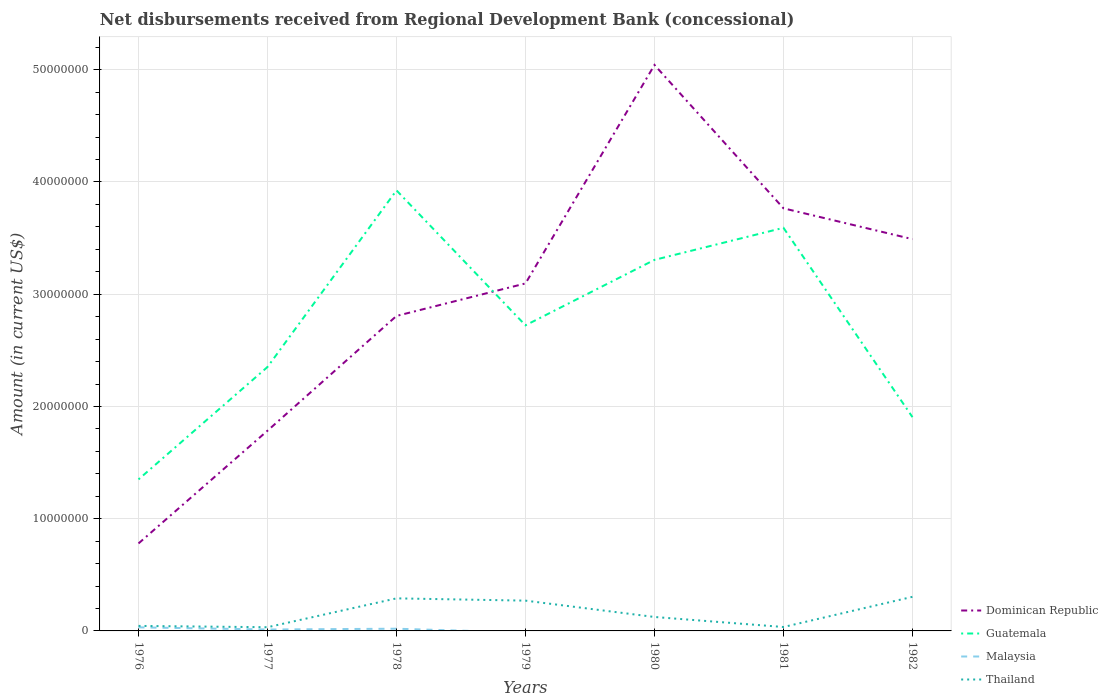Does the line corresponding to Dominican Republic intersect with the line corresponding to Thailand?
Offer a terse response. No. Across all years, what is the maximum amount of disbursements received from Regional Development Bank in Thailand?
Offer a terse response. 3.30e+05. What is the total amount of disbursements received from Regional Development Bank in Dominican Republic in the graph?
Offer a very short reply. 1.28e+07. What is the difference between the highest and the second highest amount of disbursements received from Regional Development Bank in Thailand?
Your answer should be very brief. 2.71e+06. What is the difference between the highest and the lowest amount of disbursements received from Regional Development Bank in Thailand?
Make the answer very short. 3. How many lines are there?
Your answer should be compact. 4. How many years are there in the graph?
Your response must be concise. 7. What is the difference between two consecutive major ticks on the Y-axis?
Provide a succinct answer. 1.00e+07. Where does the legend appear in the graph?
Your answer should be very brief. Bottom right. What is the title of the graph?
Your answer should be compact. Net disbursements received from Regional Development Bank (concessional). Does "Madagascar" appear as one of the legend labels in the graph?
Provide a succinct answer. No. What is the label or title of the X-axis?
Your answer should be very brief. Years. What is the label or title of the Y-axis?
Ensure brevity in your answer.  Amount (in current US$). What is the Amount (in current US$) of Dominican Republic in 1976?
Offer a very short reply. 7.79e+06. What is the Amount (in current US$) in Guatemala in 1976?
Make the answer very short. 1.35e+07. What is the Amount (in current US$) of Malaysia in 1976?
Offer a very short reply. 3.18e+05. What is the Amount (in current US$) in Thailand in 1976?
Provide a short and direct response. 4.47e+05. What is the Amount (in current US$) of Dominican Republic in 1977?
Provide a succinct answer. 1.78e+07. What is the Amount (in current US$) of Guatemala in 1977?
Make the answer very short. 2.35e+07. What is the Amount (in current US$) in Malaysia in 1977?
Your answer should be very brief. 1.26e+05. What is the Amount (in current US$) of Thailand in 1977?
Make the answer very short. 3.30e+05. What is the Amount (in current US$) of Dominican Republic in 1978?
Your answer should be very brief. 2.81e+07. What is the Amount (in current US$) in Guatemala in 1978?
Your response must be concise. 3.93e+07. What is the Amount (in current US$) of Malaysia in 1978?
Make the answer very short. 1.97e+05. What is the Amount (in current US$) in Thailand in 1978?
Your response must be concise. 2.90e+06. What is the Amount (in current US$) in Dominican Republic in 1979?
Your response must be concise. 3.10e+07. What is the Amount (in current US$) of Guatemala in 1979?
Ensure brevity in your answer.  2.72e+07. What is the Amount (in current US$) in Malaysia in 1979?
Your response must be concise. 0. What is the Amount (in current US$) of Thailand in 1979?
Your answer should be very brief. 2.70e+06. What is the Amount (in current US$) in Dominican Republic in 1980?
Give a very brief answer. 5.04e+07. What is the Amount (in current US$) in Guatemala in 1980?
Your response must be concise. 3.31e+07. What is the Amount (in current US$) of Thailand in 1980?
Provide a succinct answer. 1.24e+06. What is the Amount (in current US$) in Dominican Republic in 1981?
Your answer should be very brief. 3.77e+07. What is the Amount (in current US$) in Guatemala in 1981?
Ensure brevity in your answer.  3.59e+07. What is the Amount (in current US$) of Thailand in 1981?
Keep it short and to the point. 3.49e+05. What is the Amount (in current US$) of Dominican Republic in 1982?
Your answer should be very brief. 3.49e+07. What is the Amount (in current US$) in Guatemala in 1982?
Provide a succinct answer. 1.90e+07. What is the Amount (in current US$) in Malaysia in 1982?
Provide a short and direct response. 0. What is the Amount (in current US$) in Thailand in 1982?
Your answer should be compact. 3.04e+06. Across all years, what is the maximum Amount (in current US$) in Dominican Republic?
Make the answer very short. 5.04e+07. Across all years, what is the maximum Amount (in current US$) in Guatemala?
Give a very brief answer. 3.93e+07. Across all years, what is the maximum Amount (in current US$) in Malaysia?
Your response must be concise. 3.18e+05. Across all years, what is the maximum Amount (in current US$) of Thailand?
Offer a very short reply. 3.04e+06. Across all years, what is the minimum Amount (in current US$) in Dominican Republic?
Offer a very short reply. 7.79e+06. Across all years, what is the minimum Amount (in current US$) of Guatemala?
Ensure brevity in your answer.  1.35e+07. Across all years, what is the minimum Amount (in current US$) of Malaysia?
Your answer should be very brief. 0. What is the total Amount (in current US$) of Dominican Republic in the graph?
Make the answer very short. 2.08e+08. What is the total Amount (in current US$) of Guatemala in the graph?
Offer a very short reply. 1.92e+08. What is the total Amount (in current US$) in Malaysia in the graph?
Ensure brevity in your answer.  6.41e+05. What is the total Amount (in current US$) in Thailand in the graph?
Give a very brief answer. 1.10e+07. What is the difference between the Amount (in current US$) in Dominican Republic in 1976 and that in 1977?
Offer a very short reply. -1.00e+07. What is the difference between the Amount (in current US$) of Guatemala in 1976 and that in 1977?
Give a very brief answer. -1.00e+07. What is the difference between the Amount (in current US$) of Malaysia in 1976 and that in 1977?
Keep it short and to the point. 1.92e+05. What is the difference between the Amount (in current US$) of Thailand in 1976 and that in 1977?
Offer a very short reply. 1.17e+05. What is the difference between the Amount (in current US$) of Dominican Republic in 1976 and that in 1978?
Offer a very short reply. -2.03e+07. What is the difference between the Amount (in current US$) of Guatemala in 1976 and that in 1978?
Provide a short and direct response. -2.58e+07. What is the difference between the Amount (in current US$) in Malaysia in 1976 and that in 1978?
Offer a very short reply. 1.21e+05. What is the difference between the Amount (in current US$) of Thailand in 1976 and that in 1978?
Your answer should be compact. -2.45e+06. What is the difference between the Amount (in current US$) in Dominican Republic in 1976 and that in 1979?
Give a very brief answer. -2.32e+07. What is the difference between the Amount (in current US$) of Guatemala in 1976 and that in 1979?
Your answer should be compact. -1.37e+07. What is the difference between the Amount (in current US$) of Thailand in 1976 and that in 1979?
Provide a short and direct response. -2.25e+06. What is the difference between the Amount (in current US$) of Dominican Republic in 1976 and that in 1980?
Your answer should be very brief. -4.26e+07. What is the difference between the Amount (in current US$) in Guatemala in 1976 and that in 1980?
Provide a succinct answer. -1.96e+07. What is the difference between the Amount (in current US$) of Thailand in 1976 and that in 1980?
Keep it short and to the point. -7.95e+05. What is the difference between the Amount (in current US$) of Dominican Republic in 1976 and that in 1981?
Your response must be concise. -2.99e+07. What is the difference between the Amount (in current US$) in Guatemala in 1976 and that in 1981?
Make the answer very short. -2.24e+07. What is the difference between the Amount (in current US$) of Thailand in 1976 and that in 1981?
Your response must be concise. 9.80e+04. What is the difference between the Amount (in current US$) in Dominican Republic in 1976 and that in 1982?
Provide a short and direct response. -2.71e+07. What is the difference between the Amount (in current US$) in Guatemala in 1976 and that in 1982?
Your answer should be compact. -5.55e+06. What is the difference between the Amount (in current US$) of Thailand in 1976 and that in 1982?
Your response must be concise. -2.59e+06. What is the difference between the Amount (in current US$) in Dominican Republic in 1977 and that in 1978?
Provide a short and direct response. -1.02e+07. What is the difference between the Amount (in current US$) in Guatemala in 1977 and that in 1978?
Ensure brevity in your answer.  -1.57e+07. What is the difference between the Amount (in current US$) of Malaysia in 1977 and that in 1978?
Keep it short and to the point. -7.10e+04. What is the difference between the Amount (in current US$) in Thailand in 1977 and that in 1978?
Make the answer very short. -2.57e+06. What is the difference between the Amount (in current US$) in Dominican Republic in 1977 and that in 1979?
Provide a short and direct response. -1.31e+07. What is the difference between the Amount (in current US$) in Guatemala in 1977 and that in 1979?
Give a very brief answer. -3.71e+06. What is the difference between the Amount (in current US$) of Thailand in 1977 and that in 1979?
Provide a short and direct response. -2.37e+06. What is the difference between the Amount (in current US$) of Dominican Republic in 1977 and that in 1980?
Provide a short and direct response. -3.26e+07. What is the difference between the Amount (in current US$) of Guatemala in 1977 and that in 1980?
Your response must be concise. -9.54e+06. What is the difference between the Amount (in current US$) in Thailand in 1977 and that in 1980?
Ensure brevity in your answer.  -9.12e+05. What is the difference between the Amount (in current US$) of Dominican Republic in 1977 and that in 1981?
Offer a terse response. -1.98e+07. What is the difference between the Amount (in current US$) in Guatemala in 1977 and that in 1981?
Provide a succinct answer. -1.24e+07. What is the difference between the Amount (in current US$) in Thailand in 1977 and that in 1981?
Your answer should be compact. -1.90e+04. What is the difference between the Amount (in current US$) in Dominican Republic in 1977 and that in 1982?
Provide a short and direct response. -1.71e+07. What is the difference between the Amount (in current US$) of Guatemala in 1977 and that in 1982?
Keep it short and to the point. 4.47e+06. What is the difference between the Amount (in current US$) in Thailand in 1977 and that in 1982?
Your answer should be very brief. -2.71e+06. What is the difference between the Amount (in current US$) of Dominican Republic in 1978 and that in 1979?
Provide a succinct answer. -2.90e+06. What is the difference between the Amount (in current US$) of Guatemala in 1978 and that in 1979?
Give a very brief answer. 1.20e+07. What is the difference between the Amount (in current US$) in Thailand in 1978 and that in 1979?
Offer a terse response. 2.03e+05. What is the difference between the Amount (in current US$) of Dominican Republic in 1978 and that in 1980?
Your answer should be very brief. -2.24e+07. What is the difference between the Amount (in current US$) in Guatemala in 1978 and that in 1980?
Ensure brevity in your answer.  6.19e+06. What is the difference between the Amount (in current US$) in Thailand in 1978 and that in 1980?
Your answer should be compact. 1.66e+06. What is the difference between the Amount (in current US$) of Dominican Republic in 1978 and that in 1981?
Offer a terse response. -9.59e+06. What is the difference between the Amount (in current US$) of Guatemala in 1978 and that in 1981?
Offer a terse response. 3.34e+06. What is the difference between the Amount (in current US$) of Thailand in 1978 and that in 1981?
Give a very brief answer. 2.55e+06. What is the difference between the Amount (in current US$) in Dominican Republic in 1978 and that in 1982?
Give a very brief answer. -6.84e+06. What is the difference between the Amount (in current US$) in Guatemala in 1978 and that in 1982?
Ensure brevity in your answer.  2.02e+07. What is the difference between the Amount (in current US$) of Thailand in 1978 and that in 1982?
Your answer should be very brief. -1.37e+05. What is the difference between the Amount (in current US$) in Dominican Republic in 1979 and that in 1980?
Provide a succinct answer. -1.95e+07. What is the difference between the Amount (in current US$) in Guatemala in 1979 and that in 1980?
Give a very brief answer. -5.83e+06. What is the difference between the Amount (in current US$) of Thailand in 1979 and that in 1980?
Ensure brevity in your answer.  1.46e+06. What is the difference between the Amount (in current US$) of Dominican Republic in 1979 and that in 1981?
Your answer should be compact. -6.69e+06. What is the difference between the Amount (in current US$) of Guatemala in 1979 and that in 1981?
Make the answer very short. -8.69e+06. What is the difference between the Amount (in current US$) in Thailand in 1979 and that in 1981?
Keep it short and to the point. 2.35e+06. What is the difference between the Amount (in current US$) in Dominican Republic in 1979 and that in 1982?
Your answer should be compact. -3.95e+06. What is the difference between the Amount (in current US$) in Guatemala in 1979 and that in 1982?
Ensure brevity in your answer.  8.18e+06. What is the difference between the Amount (in current US$) in Dominican Republic in 1980 and that in 1981?
Make the answer very short. 1.28e+07. What is the difference between the Amount (in current US$) of Guatemala in 1980 and that in 1981?
Keep it short and to the point. -2.86e+06. What is the difference between the Amount (in current US$) in Thailand in 1980 and that in 1981?
Keep it short and to the point. 8.93e+05. What is the difference between the Amount (in current US$) in Dominican Republic in 1980 and that in 1982?
Ensure brevity in your answer.  1.55e+07. What is the difference between the Amount (in current US$) of Guatemala in 1980 and that in 1982?
Offer a terse response. 1.40e+07. What is the difference between the Amount (in current US$) in Thailand in 1980 and that in 1982?
Give a very brief answer. -1.80e+06. What is the difference between the Amount (in current US$) in Dominican Republic in 1981 and that in 1982?
Provide a succinct answer. 2.75e+06. What is the difference between the Amount (in current US$) in Guatemala in 1981 and that in 1982?
Keep it short and to the point. 1.69e+07. What is the difference between the Amount (in current US$) in Thailand in 1981 and that in 1982?
Offer a very short reply. -2.69e+06. What is the difference between the Amount (in current US$) in Dominican Republic in 1976 and the Amount (in current US$) in Guatemala in 1977?
Offer a very short reply. -1.57e+07. What is the difference between the Amount (in current US$) in Dominican Republic in 1976 and the Amount (in current US$) in Malaysia in 1977?
Your answer should be compact. 7.67e+06. What is the difference between the Amount (in current US$) in Dominican Republic in 1976 and the Amount (in current US$) in Thailand in 1977?
Offer a very short reply. 7.46e+06. What is the difference between the Amount (in current US$) in Guatemala in 1976 and the Amount (in current US$) in Malaysia in 1977?
Provide a short and direct response. 1.34e+07. What is the difference between the Amount (in current US$) of Guatemala in 1976 and the Amount (in current US$) of Thailand in 1977?
Offer a very short reply. 1.32e+07. What is the difference between the Amount (in current US$) in Malaysia in 1976 and the Amount (in current US$) in Thailand in 1977?
Offer a terse response. -1.20e+04. What is the difference between the Amount (in current US$) in Dominican Republic in 1976 and the Amount (in current US$) in Guatemala in 1978?
Your answer should be compact. -3.15e+07. What is the difference between the Amount (in current US$) of Dominican Republic in 1976 and the Amount (in current US$) of Malaysia in 1978?
Offer a terse response. 7.60e+06. What is the difference between the Amount (in current US$) of Dominican Republic in 1976 and the Amount (in current US$) of Thailand in 1978?
Your answer should be compact. 4.89e+06. What is the difference between the Amount (in current US$) in Guatemala in 1976 and the Amount (in current US$) in Malaysia in 1978?
Give a very brief answer. 1.33e+07. What is the difference between the Amount (in current US$) of Guatemala in 1976 and the Amount (in current US$) of Thailand in 1978?
Provide a succinct answer. 1.06e+07. What is the difference between the Amount (in current US$) in Malaysia in 1976 and the Amount (in current US$) in Thailand in 1978?
Give a very brief answer. -2.58e+06. What is the difference between the Amount (in current US$) of Dominican Republic in 1976 and the Amount (in current US$) of Guatemala in 1979?
Offer a very short reply. -1.94e+07. What is the difference between the Amount (in current US$) of Dominican Republic in 1976 and the Amount (in current US$) of Thailand in 1979?
Offer a very short reply. 5.10e+06. What is the difference between the Amount (in current US$) of Guatemala in 1976 and the Amount (in current US$) of Thailand in 1979?
Offer a terse response. 1.08e+07. What is the difference between the Amount (in current US$) in Malaysia in 1976 and the Amount (in current US$) in Thailand in 1979?
Ensure brevity in your answer.  -2.38e+06. What is the difference between the Amount (in current US$) in Dominican Republic in 1976 and the Amount (in current US$) in Guatemala in 1980?
Provide a short and direct response. -2.53e+07. What is the difference between the Amount (in current US$) of Dominican Republic in 1976 and the Amount (in current US$) of Thailand in 1980?
Your response must be concise. 6.55e+06. What is the difference between the Amount (in current US$) of Guatemala in 1976 and the Amount (in current US$) of Thailand in 1980?
Offer a terse response. 1.23e+07. What is the difference between the Amount (in current US$) in Malaysia in 1976 and the Amount (in current US$) in Thailand in 1980?
Provide a succinct answer. -9.24e+05. What is the difference between the Amount (in current US$) in Dominican Republic in 1976 and the Amount (in current US$) in Guatemala in 1981?
Make the answer very short. -2.81e+07. What is the difference between the Amount (in current US$) in Dominican Republic in 1976 and the Amount (in current US$) in Thailand in 1981?
Your response must be concise. 7.44e+06. What is the difference between the Amount (in current US$) of Guatemala in 1976 and the Amount (in current US$) of Thailand in 1981?
Keep it short and to the point. 1.32e+07. What is the difference between the Amount (in current US$) in Malaysia in 1976 and the Amount (in current US$) in Thailand in 1981?
Keep it short and to the point. -3.10e+04. What is the difference between the Amount (in current US$) in Dominican Republic in 1976 and the Amount (in current US$) in Guatemala in 1982?
Make the answer very short. -1.13e+07. What is the difference between the Amount (in current US$) in Dominican Republic in 1976 and the Amount (in current US$) in Thailand in 1982?
Give a very brief answer. 4.76e+06. What is the difference between the Amount (in current US$) in Guatemala in 1976 and the Amount (in current US$) in Thailand in 1982?
Keep it short and to the point. 1.05e+07. What is the difference between the Amount (in current US$) in Malaysia in 1976 and the Amount (in current US$) in Thailand in 1982?
Offer a very short reply. -2.72e+06. What is the difference between the Amount (in current US$) of Dominican Republic in 1977 and the Amount (in current US$) of Guatemala in 1978?
Provide a short and direct response. -2.14e+07. What is the difference between the Amount (in current US$) in Dominican Republic in 1977 and the Amount (in current US$) in Malaysia in 1978?
Provide a succinct answer. 1.76e+07. What is the difference between the Amount (in current US$) in Dominican Republic in 1977 and the Amount (in current US$) in Thailand in 1978?
Make the answer very short. 1.49e+07. What is the difference between the Amount (in current US$) in Guatemala in 1977 and the Amount (in current US$) in Malaysia in 1978?
Your answer should be very brief. 2.33e+07. What is the difference between the Amount (in current US$) in Guatemala in 1977 and the Amount (in current US$) in Thailand in 1978?
Your answer should be compact. 2.06e+07. What is the difference between the Amount (in current US$) in Malaysia in 1977 and the Amount (in current US$) in Thailand in 1978?
Provide a succinct answer. -2.78e+06. What is the difference between the Amount (in current US$) in Dominican Republic in 1977 and the Amount (in current US$) in Guatemala in 1979?
Offer a very short reply. -9.39e+06. What is the difference between the Amount (in current US$) of Dominican Republic in 1977 and the Amount (in current US$) of Thailand in 1979?
Your answer should be compact. 1.51e+07. What is the difference between the Amount (in current US$) in Guatemala in 1977 and the Amount (in current US$) in Thailand in 1979?
Offer a very short reply. 2.08e+07. What is the difference between the Amount (in current US$) in Malaysia in 1977 and the Amount (in current US$) in Thailand in 1979?
Your answer should be compact. -2.57e+06. What is the difference between the Amount (in current US$) in Dominican Republic in 1977 and the Amount (in current US$) in Guatemala in 1980?
Your answer should be compact. -1.52e+07. What is the difference between the Amount (in current US$) in Dominican Republic in 1977 and the Amount (in current US$) in Thailand in 1980?
Provide a short and direct response. 1.66e+07. What is the difference between the Amount (in current US$) of Guatemala in 1977 and the Amount (in current US$) of Thailand in 1980?
Your answer should be very brief. 2.23e+07. What is the difference between the Amount (in current US$) of Malaysia in 1977 and the Amount (in current US$) of Thailand in 1980?
Your answer should be compact. -1.12e+06. What is the difference between the Amount (in current US$) in Dominican Republic in 1977 and the Amount (in current US$) in Guatemala in 1981?
Your response must be concise. -1.81e+07. What is the difference between the Amount (in current US$) in Dominican Republic in 1977 and the Amount (in current US$) in Thailand in 1981?
Make the answer very short. 1.75e+07. What is the difference between the Amount (in current US$) of Guatemala in 1977 and the Amount (in current US$) of Thailand in 1981?
Keep it short and to the point. 2.32e+07. What is the difference between the Amount (in current US$) in Malaysia in 1977 and the Amount (in current US$) in Thailand in 1981?
Give a very brief answer. -2.23e+05. What is the difference between the Amount (in current US$) of Dominican Republic in 1977 and the Amount (in current US$) of Guatemala in 1982?
Your answer should be very brief. -1.21e+06. What is the difference between the Amount (in current US$) of Dominican Republic in 1977 and the Amount (in current US$) of Thailand in 1982?
Give a very brief answer. 1.48e+07. What is the difference between the Amount (in current US$) of Guatemala in 1977 and the Amount (in current US$) of Thailand in 1982?
Offer a terse response. 2.05e+07. What is the difference between the Amount (in current US$) in Malaysia in 1977 and the Amount (in current US$) in Thailand in 1982?
Offer a terse response. -2.91e+06. What is the difference between the Amount (in current US$) in Dominican Republic in 1978 and the Amount (in current US$) in Guatemala in 1979?
Your answer should be compact. 8.38e+05. What is the difference between the Amount (in current US$) in Dominican Republic in 1978 and the Amount (in current US$) in Thailand in 1979?
Your answer should be compact. 2.54e+07. What is the difference between the Amount (in current US$) of Guatemala in 1978 and the Amount (in current US$) of Thailand in 1979?
Offer a terse response. 3.66e+07. What is the difference between the Amount (in current US$) of Malaysia in 1978 and the Amount (in current US$) of Thailand in 1979?
Make the answer very short. -2.50e+06. What is the difference between the Amount (in current US$) of Dominican Republic in 1978 and the Amount (in current US$) of Guatemala in 1980?
Offer a very short reply. -5.00e+06. What is the difference between the Amount (in current US$) in Dominican Republic in 1978 and the Amount (in current US$) in Thailand in 1980?
Your response must be concise. 2.68e+07. What is the difference between the Amount (in current US$) in Guatemala in 1978 and the Amount (in current US$) in Thailand in 1980?
Offer a terse response. 3.80e+07. What is the difference between the Amount (in current US$) in Malaysia in 1978 and the Amount (in current US$) in Thailand in 1980?
Your response must be concise. -1.04e+06. What is the difference between the Amount (in current US$) of Dominican Republic in 1978 and the Amount (in current US$) of Guatemala in 1981?
Provide a succinct answer. -7.85e+06. What is the difference between the Amount (in current US$) of Dominican Republic in 1978 and the Amount (in current US$) of Thailand in 1981?
Keep it short and to the point. 2.77e+07. What is the difference between the Amount (in current US$) of Guatemala in 1978 and the Amount (in current US$) of Thailand in 1981?
Provide a succinct answer. 3.89e+07. What is the difference between the Amount (in current US$) in Malaysia in 1978 and the Amount (in current US$) in Thailand in 1981?
Provide a short and direct response. -1.52e+05. What is the difference between the Amount (in current US$) in Dominican Republic in 1978 and the Amount (in current US$) in Guatemala in 1982?
Your response must be concise. 9.02e+06. What is the difference between the Amount (in current US$) of Dominican Republic in 1978 and the Amount (in current US$) of Thailand in 1982?
Offer a terse response. 2.50e+07. What is the difference between the Amount (in current US$) of Guatemala in 1978 and the Amount (in current US$) of Thailand in 1982?
Keep it short and to the point. 3.62e+07. What is the difference between the Amount (in current US$) of Malaysia in 1978 and the Amount (in current US$) of Thailand in 1982?
Ensure brevity in your answer.  -2.84e+06. What is the difference between the Amount (in current US$) in Dominican Republic in 1979 and the Amount (in current US$) in Guatemala in 1980?
Ensure brevity in your answer.  -2.10e+06. What is the difference between the Amount (in current US$) in Dominican Republic in 1979 and the Amount (in current US$) in Thailand in 1980?
Your answer should be very brief. 2.97e+07. What is the difference between the Amount (in current US$) in Guatemala in 1979 and the Amount (in current US$) in Thailand in 1980?
Your answer should be compact. 2.60e+07. What is the difference between the Amount (in current US$) of Dominican Republic in 1979 and the Amount (in current US$) of Guatemala in 1981?
Your response must be concise. -4.96e+06. What is the difference between the Amount (in current US$) in Dominican Republic in 1979 and the Amount (in current US$) in Thailand in 1981?
Make the answer very short. 3.06e+07. What is the difference between the Amount (in current US$) in Guatemala in 1979 and the Amount (in current US$) in Thailand in 1981?
Offer a very short reply. 2.69e+07. What is the difference between the Amount (in current US$) in Dominican Republic in 1979 and the Amount (in current US$) in Guatemala in 1982?
Give a very brief answer. 1.19e+07. What is the difference between the Amount (in current US$) in Dominican Republic in 1979 and the Amount (in current US$) in Thailand in 1982?
Your response must be concise. 2.79e+07. What is the difference between the Amount (in current US$) of Guatemala in 1979 and the Amount (in current US$) of Thailand in 1982?
Give a very brief answer. 2.42e+07. What is the difference between the Amount (in current US$) in Dominican Republic in 1980 and the Amount (in current US$) in Guatemala in 1981?
Give a very brief answer. 1.45e+07. What is the difference between the Amount (in current US$) in Dominican Republic in 1980 and the Amount (in current US$) in Thailand in 1981?
Make the answer very short. 5.01e+07. What is the difference between the Amount (in current US$) of Guatemala in 1980 and the Amount (in current US$) of Thailand in 1981?
Ensure brevity in your answer.  3.27e+07. What is the difference between the Amount (in current US$) of Dominican Republic in 1980 and the Amount (in current US$) of Guatemala in 1982?
Keep it short and to the point. 3.14e+07. What is the difference between the Amount (in current US$) of Dominican Republic in 1980 and the Amount (in current US$) of Thailand in 1982?
Provide a short and direct response. 4.74e+07. What is the difference between the Amount (in current US$) in Guatemala in 1980 and the Amount (in current US$) in Thailand in 1982?
Offer a very short reply. 3.00e+07. What is the difference between the Amount (in current US$) in Dominican Republic in 1981 and the Amount (in current US$) in Guatemala in 1982?
Offer a very short reply. 1.86e+07. What is the difference between the Amount (in current US$) of Dominican Republic in 1981 and the Amount (in current US$) of Thailand in 1982?
Provide a short and direct response. 3.46e+07. What is the difference between the Amount (in current US$) of Guatemala in 1981 and the Amount (in current US$) of Thailand in 1982?
Offer a terse response. 3.29e+07. What is the average Amount (in current US$) in Dominican Republic per year?
Provide a succinct answer. 2.97e+07. What is the average Amount (in current US$) of Guatemala per year?
Keep it short and to the point. 2.74e+07. What is the average Amount (in current US$) of Malaysia per year?
Provide a short and direct response. 9.16e+04. What is the average Amount (in current US$) in Thailand per year?
Keep it short and to the point. 1.57e+06. In the year 1976, what is the difference between the Amount (in current US$) in Dominican Republic and Amount (in current US$) in Guatemala?
Make the answer very short. -5.71e+06. In the year 1976, what is the difference between the Amount (in current US$) in Dominican Republic and Amount (in current US$) in Malaysia?
Ensure brevity in your answer.  7.48e+06. In the year 1976, what is the difference between the Amount (in current US$) of Dominican Republic and Amount (in current US$) of Thailand?
Provide a succinct answer. 7.35e+06. In the year 1976, what is the difference between the Amount (in current US$) of Guatemala and Amount (in current US$) of Malaysia?
Your answer should be compact. 1.32e+07. In the year 1976, what is the difference between the Amount (in current US$) in Guatemala and Amount (in current US$) in Thailand?
Provide a short and direct response. 1.31e+07. In the year 1976, what is the difference between the Amount (in current US$) of Malaysia and Amount (in current US$) of Thailand?
Offer a very short reply. -1.29e+05. In the year 1977, what is the difference between the Amount (in current US$) of Dominican Republic and Amount (in current US$) of Guatemala?
Your answer should be very brief. -5.68e+06. In the year 1977, what is the difference between the Amount (in current US$) in Dominican Republic and Amount (in current US$) in Malaysia?
Give a very brief answer. 1.77e+07. In the year 1977, what is the difference between the Amount (in current US$) in Dominican Republic and Amount (in current US$) in Thailand?
Your answer should be compact. 1.75e+07. In the year 1977, what is the difference between the Amount (in current US$) of Guatemala and Amount (in current US$) of Malaysia?
Your answer should be very brief. 2.34e+07. In the year 1977, what is the difference between the Amount (in current US$) of Guatemala and Amount (in current US$) of Thailand?
Provide a short and direct response. 2.32e+07. In the year 1977, what is the difference between the Amount (in current US$) of Malaysia and Amount (in current US$) of Thailand?
Your response must be concise. -2.04e+05. In the year 1978, what is the difference between the Amount (in current US$) of Dominican Republic and Amount (in current US$) of Guatemala?
Provide a succinct answer. -1.12e+07. In the year 1978, what is the difference between the Amount (in current US$) in Dominican Republic and Amount (in current US$) in Malaysia?
Your response must be concise. 2.79e+07. In the year 1978, what is the difference between the Amount (in current US$) of Dominican Republic and Amount (in current US$) of Thailand?
Offer a very short reply. 2.52e+07. In the year 1978, what is the difference between the Amount (in current US$) of Guatemala and Amount (in current US$) of Malaysia?
Ensure brevity in your answer.  3.91e+07. In the year 1978, what is the difference between the Amount (in current US$) of Guatemala and Amount (in current US$) of Thailand?
Provide a succinct answer. 3.64e+07. In the year 1978, what is the difference between the Amount (in current US$) in Malaysia and Amount (in current US$) in Thailand?
Your answer should be compact. -2.70e+06. In the year 1979, what is the difference between the Amount (in current US$) of Dominican Republic and Amount (in current US$) of Guatemala?
Offer a very short reply. 3.73e+06. In the year 1979, what is the difference between the Amount (in current US$) in Dominican Republic and Amount (in current US$) in Thailand?
Your answer should be very brief. 2.83e+07. In the year 1979, what is the difference between the Amount (in current US$) in Guatemala and Amount (in current US$) in Thailand?
Make the answer very short. 2.45e+07. In the year 1980, what is the difference between the Amount (in current US$) of Dominican Republic and Amount (in current US$) of Guatemala?
Offer a very short reply. 1.74e+07. In the year 1980, what is the difference between the Amount (in current US$) of Dominican Republic and Amount (in current US$) of Thailand?
Your response must be concise. 4.92e+07. In the year 1980, what is the difference between the Amount (in current US$) in Guatemala and Amount (in current US$) in Thailand?
Give a very brief answer. 3.18e+07. In the year 1981, what is the difference between the Amount (in current US$) of Dominican Republic and Amount (in current US$) of Guatemala?
Give a very brief answer. 1.74e+06. In the year 1981, what is the difference between the Amount (in current US$) of Dominican Republic and Amount (in current US$) of Thailand?
Your answer should be very brief. 3.73e+07. In the year 1981, what is the difference between the Amount (in current US$) in Guatemala and Amount (in current US$) in Thailand?
Ensure brevity in your answer.  3.56e+07. In the year 1982, what is the difference between the Amount (in current US$) of Dominican Republic and Amount (in current US$) of Guatemala?
Keep it short and to the point. 1.59e+07. In the year 1982, what is the difference between the Amount (in current US$) in Dominican Republic and Amount (in current US$) in Thailand?
Keep it short and to the point. 3.19e+07. In the year 1982, what is the difference between the Amount (in current US$) in Guatemala and Amount (in current US$) in Thailand?
Make the answer very short. 1.60e+07. What is the ratio of the Amount (in current US$) in Dominican Republic in 1976 to that in 1977?
Make the answer very short. 0.44. What is the ratio of the Amount (in current US$) in Guatemala in 1976 to that in 1977?
Your answer should be compact. 0.57. What is the ratio of the Amount (in current US$) in Malaysia in 1976 to that in 1977?
Keep it short and to the point. 2.52. What is the ratio of the Amount (in current US$) of Thailand in 1976 to that in 1977?
Provide a succinct answer. 1.35. What is the ratio of the Amount (in current US$) of Dominican Republic in 1976 to that in 1978?
Provide a succinct answer. 0.28. What is the ratio of the Amount (in current US$) of Guatemala in 1976 to that in 1978?
Give a very brief answer. 0.34. What is the ratio of the Amount (in current US$) of Malaysia in 1976 to that in 1978?
Provide a succinct answer. 1.61. What is the ratio of the Amount (in current US$) in Thailand in 1976 to that in 1978?
Your response must be concise. 0.15. What is the ratio of the Amount (in current US$) in Dominican Republic in 1976 to that in 1979?
Provide a succinct answer. 0.25. What is the ratio of the Amount (in current US$) in Guatemala in 1976 to that in 1979?
Ensure brevity in your answer.  0.5. What is the ratio of the Amount (in current US$) of Thailand in 1976 to that in 1979?
Provide a short and direct response. 0.17. What is the ratio of the Amount (in current US$) in Dominican Republic in 1976 to that in 1980?
Offer a terse response. 0.15. What is the ratio of the Amount (in current US$) of Guatemala in 1976 to that in 1980?
Ensure brevity in your answer.  0.41. What is the ratio of the Amount (in current US$) in Thailand in 1976 to that in 1980?
Ensure brevity in your answer.  0.36. What is the ratio of the Amount (in current US$) of Dominican Republic in 1976 to that in 1981?
Your answer should be very brief. 0.21. What is the ratio of the Amount (in current US$) of Guatemala in 1976 to that in 1981?
Your response must be concise. 0.38. What is the ratio of the Amount (in current US$) of Thailand in 1976 to that in 1981?
Make the answer very short. 1.28. What is the ratio of the Amount (in current US$) in Dominican Republic in 1976 to that in 1982?
Your response must be concise. 0.22. What is the ratio of the Amount (in current US$) of Guatemala in 1976 to that in 1982?
Ensure brevity in your answer.  0.71. What is the ratio of the Amount (in current US$) of Thailand in 1976 to that in 1982?
Provide a short and direct response. 0.15. What is the ratio of the Amount (in current US$) in Dominican Republic in 1977 to that in 1978?
Your answer should be very brief. 0.64. What is the ratio of the Amount (in current US$) of Guatemala in 1977 to that in 1978?
Make the answer very short. 0.6. What is the ratio of the Amount (in current US$) of Malaysia in 1977 to that in 1978?
Give a very brief answer. 0.64. What is the ratio of the Amount (in current US$) in Thailand in 1977 to that in 1978?
Your answer should be very brief. 0.11. What is the ratio of the Amount (in current US$) of Dominican Republic in 1977 to that in 1979?
Offer a very short reply. 0.58. What is the ratio of the Amount (in current US$) of Guatemala in 1977 to that in 1979?
Provide a short and direct response. 0.86. What is the ratio of the Amount (in current US$) of Thailand in 1977 to that in 1979?
Your answer should be compact. 0.12. What is the ratio of the Amount (in current US$) of Dominican Republic in 1977 to that in 1980?
Provide a short and direct response. 0.35. What is the ratio of the Amount (in current US$) of Guatemala in 1977 to that in 1980?
Your response must be concise. 0.71. What is the ratio of the Amount (in current US$) of Thailand in 1977 to that in 1980?
Make the answer very short. 0.27. What is the ratio of the Amount (in current US$) in Dominican Republic in 1977 to that in 1981?
Offer a very short reply. 0.47. What is the ratio of the Amount (in current US$) in Guatemala in 1977 to that in 1981?
Ensure brevity in your answer.  0.65. What is the ratio of the Amount (in current US$) in Thailand in 1977 to that in 1981?
Your answer should be very brief. 0.95. What is the ratio of the Amount (in current US$) in Dominican Republic in 1977 to that in 1982?
Provide a succinct answer. 0.51. What is the ratio of the Amount (in current US$) in Guatemala in 1977 to that in 1982?
Provide a succinct answer. 1.23. What is the ratio of the Amount (in current US$) of Thailand in 1977 to that in 1982?
Your answer should be compact. 0.11. What is the ratio of the Amount (in current US$) in Dominican Republic in 1978 to that in 1979?
Offer a terse response. 0.91. What is the ratio of the Amount (in current US$) in Guatemala in 1978 to that in 1979?
Make the answer very short. 1.44. What is the ratio of the Amount (in current US$) of Thailand in 1978 to that in 1979?
Give a very brief answer. 1.08. What is the ratio of the Amount (in current US$) in Dominican Republic in 1978 to that in 1980?
Your answer should be very brief. 0.56. What is the ratio of the Amount (in current US$) in Guatemala in 1978 to that in 1980?
Provide a succinct answer. 1.19. What is the ratio of the Amount (in current US$) in Thailand in 1978 to that in 1980?
Ensure brevity in your answer.  2.34. What is the ratio of the Amount (in current US$) of Dominican Republic in 1978 to that in 1981?
Offer a very short reply. 0.75. What is the ratio of the Amount (in current US$) in Guatemala in 1978 to that in 1981?
Provide a short and direct response. 1.09. What is the ratio of the Amount (in current US$) in Thailand in 1978 to that in 1981?
Your answer should be very brief. 8.31. What is the ratio of the Amount (in current US$) in Dominican Republic in 1978 to that in 1982?
Provide a short and direct response. 0.8. What is the ratio of the Amount (in current US$) in Guatemala in 1978 to that in 1982?
Make the answer very short. 2.06. What is the ratio of the Amount (in current US$) of Thailand in 1978 to that in 1982?
Give a very brief answer. 0.95. What is the ratio of the Amount (in current US$) in Dominican Republic in 1979 to that in 1980?
Provide a succinct answer. 0.61. What is the ratio of the Amount (in current US$) of Guatemala in 1979 to that in 1980?
Your answer should be compact. 0.82. What is the ratio of the Amount (in current US$) of Thailand in 1979 to that in 1980?
Offer a very short reply. 2.17. What is the ratio of the Amount (in current US$) of Dominican Republic in 1979 to that in 1981?
Your answer should be very brief. 0.82. What is the ratio of the Amount (in current US$) of Guatemala in 1979 to that in 1981?
Provide a short and direct response. 0.76. What is the ratio of the Amount (in current US$) of Thailand in 1979 to that in 1981?
Ensure brevity in your answer.  7.73. What is the ratio of the Amount (in current US$) in Dominican Republic in 1979 to that in 1982?
Offer a terse response. 0.89. What is the ratio of the Amount (in current US$) in Guatemala in 1979 to that in 1982?
Offer a very short reply. 1.43. What is the ratio of the Amount (in current US$) of Thailand in 1979 to that in 1982?
Keep it short and to the point. 0.89. What is the ratio of the Amount (in current US$) in Dominican Republic in 1980 to that in 1981?
Your response must be concise. 1.34. What is the ratio of the Amount (in current US$) of Guatemala in 1980 to that in 1981?
Make the answer very short. 0.92. What is the ratio of the Amount (in current US$) of Thailand in 1980 to that in 1981?
Keep it short and to the point. 3.56. What is the ratio of the Amount (in current US$) in Dominican Republic in 1980 to that in 1982?
Provide a short and direct response. 1.44. What is the ratio of the Amount (in current US$) of Guatemala in 1980 to that in 1982?
Ensure brevity in your answer.  1.74. What is the ratio of the Amount (in current US$) of Thailand in 1980 to that in 1982?
Offer a very short reply. 0.41. What is the ratio of the Amount (in current US$) of Dominican Republic in 1981 to that in 1982?
Offer a very short reply. 1.08. What is the ratio of the Amount (in current US$) of Guatemala in 1981 to that in 1982?
Offer a very short reply. 1.89. What is the ratio of the Amount (in current US$) of Thailand in 1981 to that in 1982?
Your response must be concise. 0.11. What is the difference between the highest and the second highest Amount (in current US$) of Dominican Republic?
Your answer should be compact. 1.28e+07. What is the difference between the highest and the second highest Amount (in current US$) in Guatemala?
Your response must be concise. 3.34e+06. What is the difference between the highest and the second highest Amount (in current US$) of Malaysia?
Offer a terse response. 1.21e+05. What is the difference between the highest and the second highest Amount (in current US$) of Thailand?
Offer a very short reply. 1.37e+05. What is the difference between the highest and the lowest Amount (in current US$) in Dominican Republic?
Keep it short and to the point. 4.26e+07. What is the difference between the highest and the lowest Amount (in current US$) in Guatemala?
Your answer should be compact. 2.58e+07. What is the difference between the highest and the lowest Amount (in current US$) in Malaysia?
Give a very brief answer. 3.18e+05. What is the difference between the highest and the lowest Amount (in current US$) of Thailand?
Keep it short and to the point. 2.71e+06. 